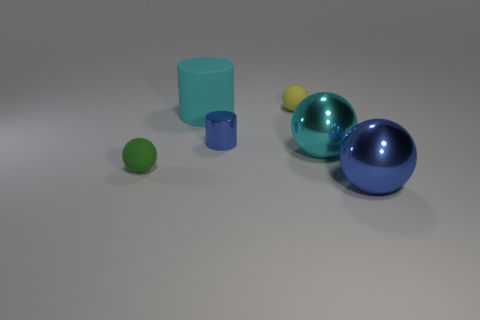Add 1 tiny green rubber spheres. How many objects exist? 7 Subtract all balls. How many objects are left? 2 Subtract all green rubber balls. Subtract all large yellow metallic things. How many objects are left? 5 Add 6 cyan rubber objects. How many cyan rubber objects are left? 7 Add 1 small metal things. How many small metal things exist? 2 Subtract 0 green cylinders. How many objects are left? 6 